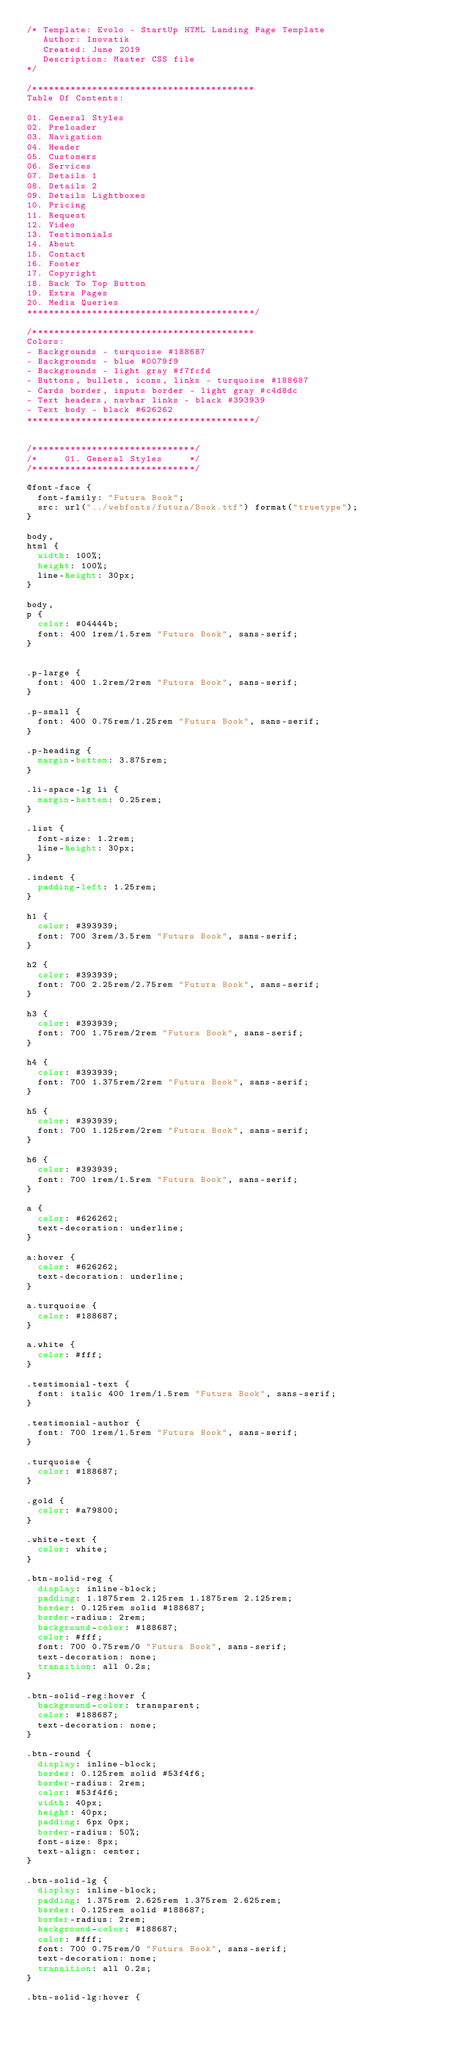<code> <loc_0><loc_0><loc_500><loc_500><_CSS_>/* Template: Evolo - StartUp HTML Landing Page Template
   Author: Inovatik
   Created: June 2019
   Description: Master CSS file
*/

/*****************************************
Table Of Contents:

01. General Styles
02. Preloader
03. Navigation
04. Header
05. Customers
06. Services
07. Details 1
08. Details 2
09. Details Lightboxes
10. Pricing
11. Request
12. Video
13. Testimonials
14. About
15. Contact
16. Footer
17. Copyright
18. Back To Top Button
19. Extra Pages
20. Media Queries
******************************************/

/*****************************************
Colors:
- Backgrounds - turquoise #188687
- Backgrounds - blue #0079f9
- Backgrounds - light gray #f7fcfd
- Buttons, bullets, icons, links - turquoise #188687
- Cards border, inputs border - light gray #c4d8dc
- Text headers, navbar links - black #393939
- Text body - black #626262
******************************************/


/******************************/
/*     01. General Styles     */
/******************************/

@font-face {
	font-family: "Futura Book";
	src: url("../webfonts/futura/Book.ttf") format("truetype");
}

body,
html {
	width: 100%;
	height: 100%;
	line-height: 30px;
}

body,
p {
	color: #04444b;
	font: 400 1rem/1.5rem "Futura Book", sans-serif;
}


.p-large {
	font: 400 1.2rem/2rem "Futura Book", sans-serif;
}

.p-small {
	font: 400 0.75rem/1.25rem "Futura Book", sans-serif;
}

.p-heading {
	margin-bottom: 3.875rem;
}

.li-space-lg li {
	margin-bottom: 0.25rem;
}

.list {
	font-size: 1.2rem;
	line-height: 30px;
}

.indent {
	padding-left: 1.25rem;
}

h1 {
	color: #393939;
	font: 700 3rem/3.5rem "Futura Book", sans-serif;
}

h2 {
	color: #393939;
	font: 700 2.25rem/2.75rem "Futura Book", sans-serif;
}

h3 {
	color: #393939;
	font: 700 1.75rem/2rem "Futura Book", sans-serif;
}

h4 {
	color: #393939;
	font: 700 1.375rem/2rem "Futura Book", sans-serif;
}

h5 {
	color: #393939;
	font: 700 1.125rem/2rem "Futura Book", sans-serif;
}

h6 {
	color: #393939;
	font: 700 1rem/1.5rem "Futura Book", sans-serif;
}

a {
	color: #626262;
	text-decoration: underline;
}

a:hover {
	color: #626262;
	text-decoration: underline;
}

a.turquoise {
	color: #188687;
}

a.white {
	color: #fff;
}

.testimonial-text {
	font: italic 400 1rem/1.5rem "Futura Book", sans-serif;
}

.testimonial-author {
	font: 700 1rem/1.5rem "Futura Book", sans-serif;
}

.turquoise {
	color: #188687;
}

.gold {
	color: #a79800;
}

.white-text {
	color: white;
}

.btn-solid-reg {
	display: inline-block;
	padding: 1.1875rem 2.125rem 1.1875rem 2.125rem;
	border: 0.125rem solid #188687;
	border-radius: 2rem;
	background-color: #188687;
	color: #fff;
	font: 700 0.75rem/0 "Futura Book", sans-serif;
	text-decoration: none;
	transition: all 0.2s;
}

.btn-solid-reg:hover {
	background-color: transparent;
	color: #188687;
	text-decoration: none;
}

.btn-round {
	display: inline-block;
	border: 0.125rem solid #53f4f6;
	border-radius: 2rem;
	color: #53f4f6;
	width: 40px;
	height: 40px;
	padding: 6px 0px;
	border-radius: 50%;
	font-size: 8px;
	text-align: center;
}

.btn-solid-lg {
	display: inline-block;
	padding: 1.375rem 2.625rem 1.375rem 2.625rem;
	border: 0.125rem solid #188687;
	border-radius: 2rem;
	background-color: #188687;
	color: #fff;
	font: 700 0.75rem/0 "Futura Book", sans-serif;
	text-decoration: none;
	transition: all 0.2s;
}

.btn-solid-lg:hover {</code> 